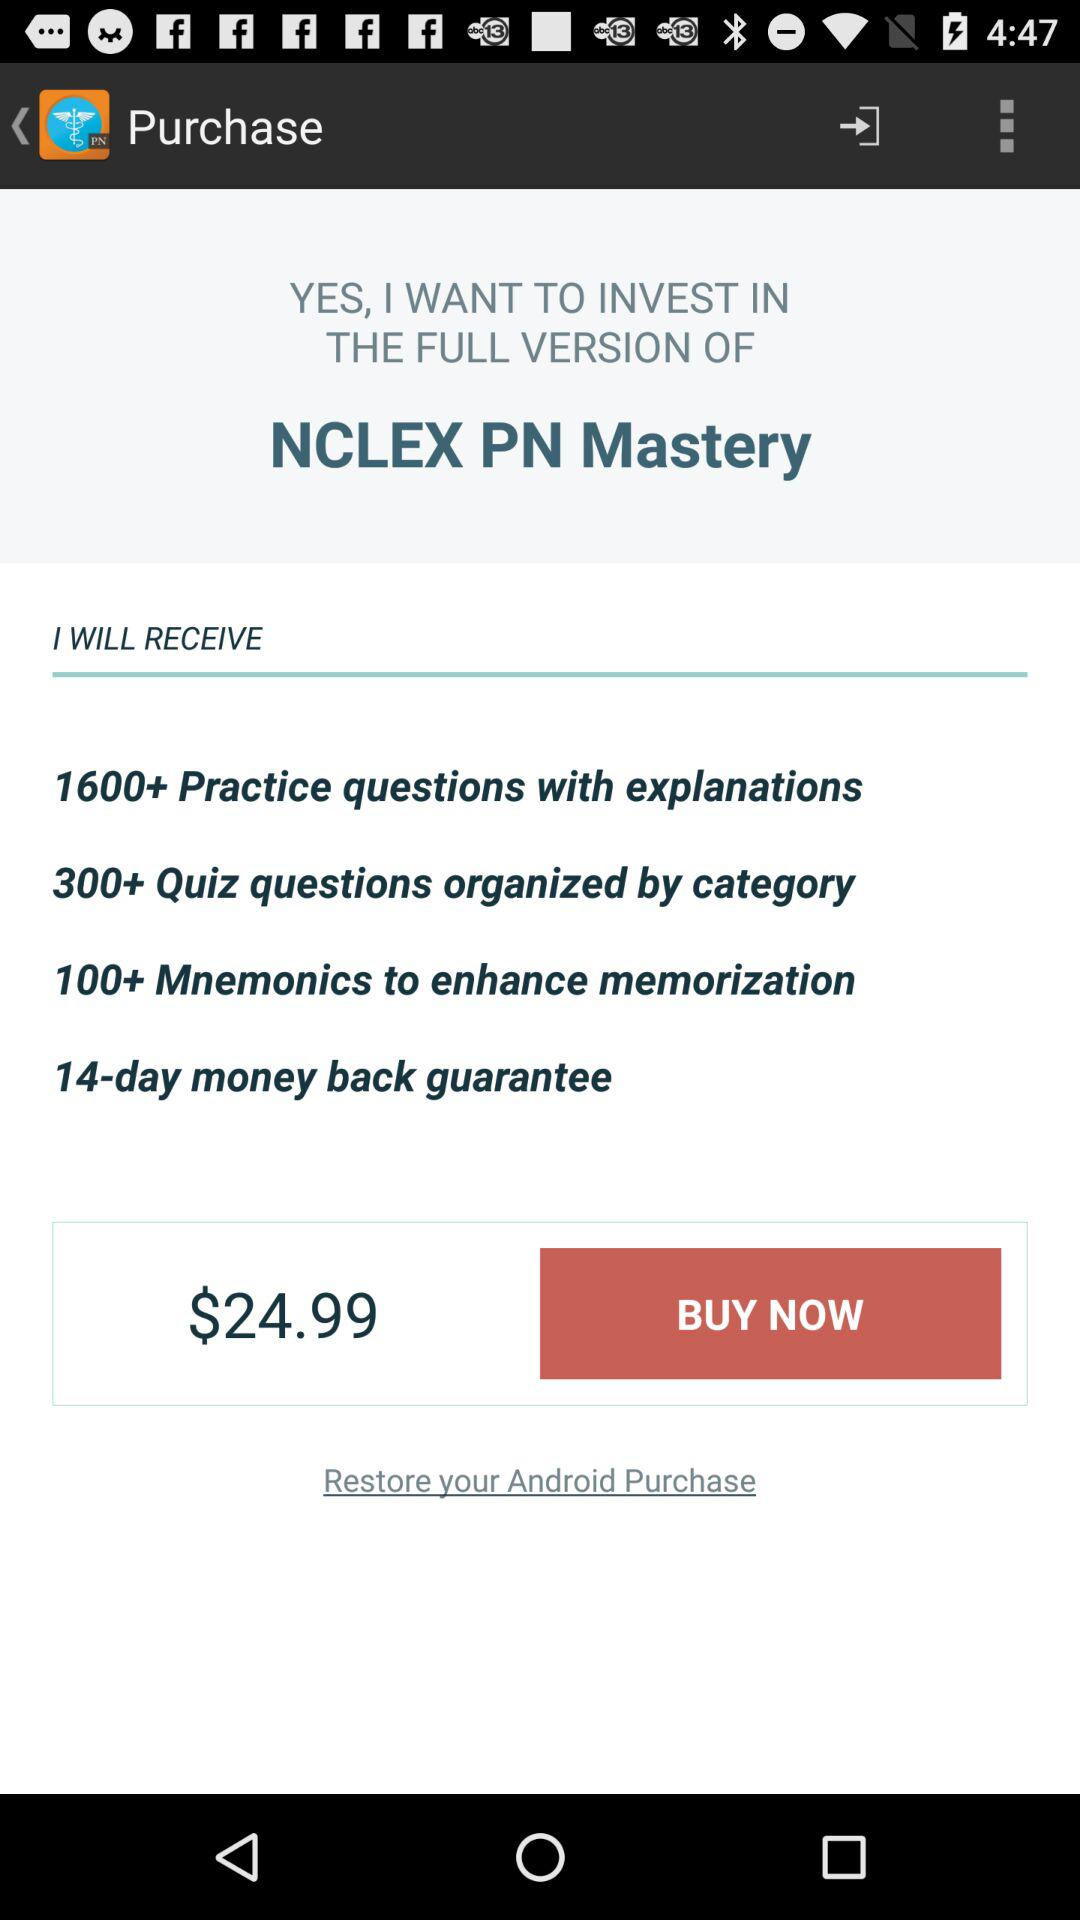How many practice questions with explanations are there? There are more than 1600 practice questions. 